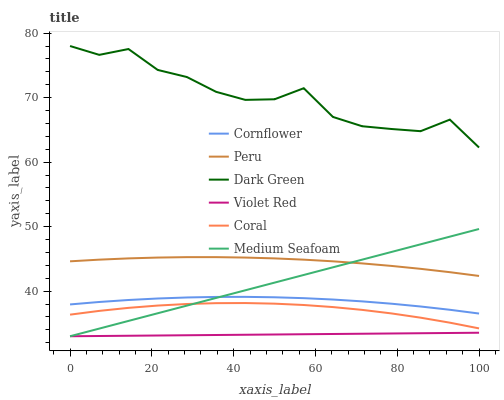Does Violet Red have the minimum area under the curve?
Answer yes or no. Yes. Does Coral have the minimum area under the curve?
Answer yes or no. No. Does Coral have the maximum area under the curve?
Answer yes or no. No. Is Dark Green the roughest?
Answer yes or no. Yes. Is Violet Red the smoothest?
Answer yes or no. No. Is Violet Red the roughest?
Answer yes or no. No. Does Coral have the lowest value?
Answer yes or no. No. Does Coral have the highest value?
Answer yes or no. No. Is Violet Red less than Cornflower?
Answer yes or no. Yes. Is Dark Green greater than Cornflower?
Answer yes or no. Yes. Does Violet Red intersect Cornflower?
Answer yes or no. No. 